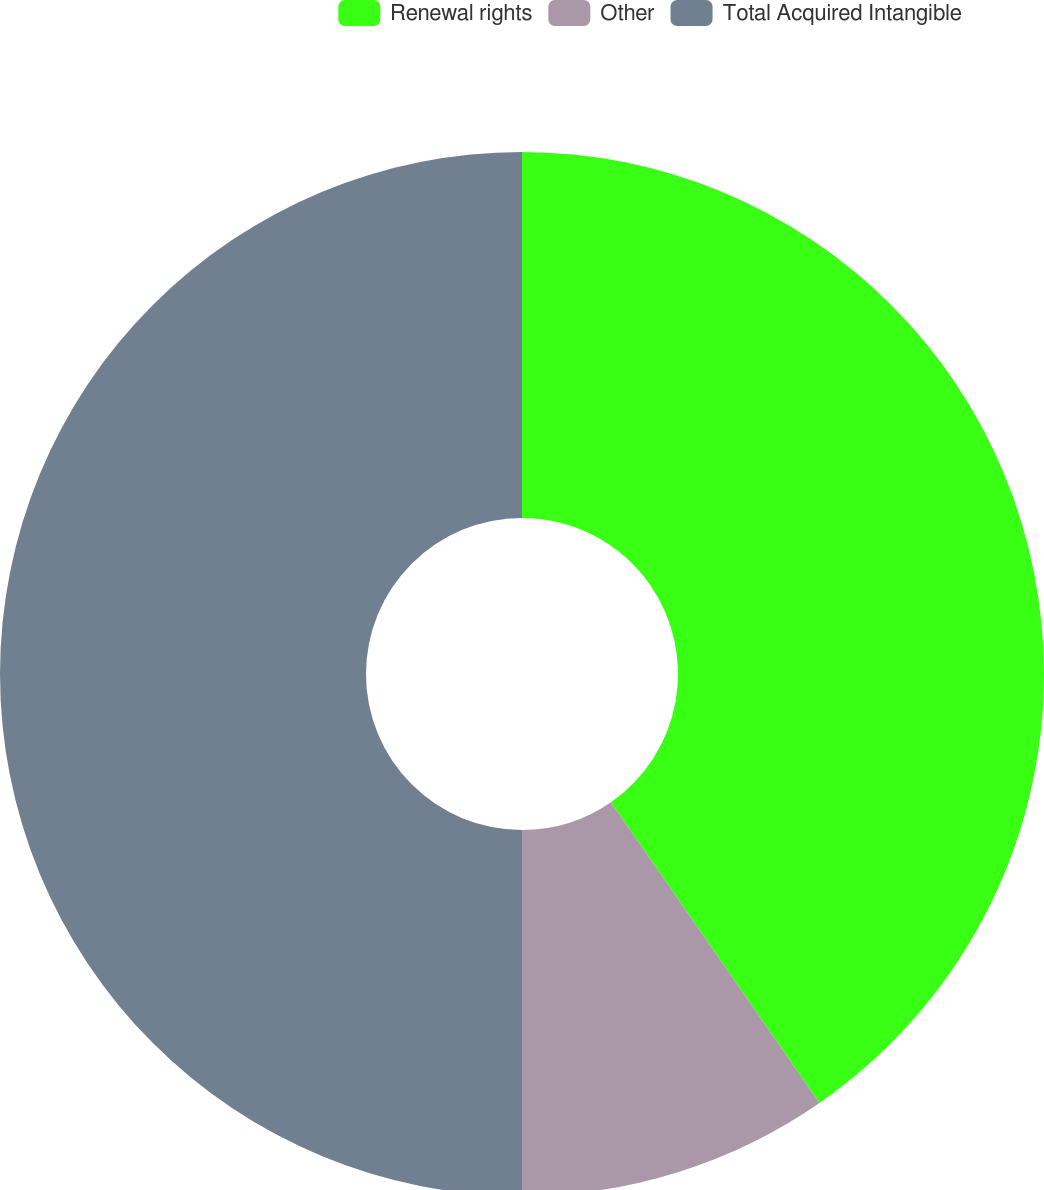Convert chart to OTSL. <chart><loc_0><loc_0><loc_500><loc_500><pie_chart><fcel>Renewal rights<fcel>Other<fcel>Total Acquired Intangible<nl><fcel>40.35%<fcel>9.65%<fcel>50.0%<nl></chart> 